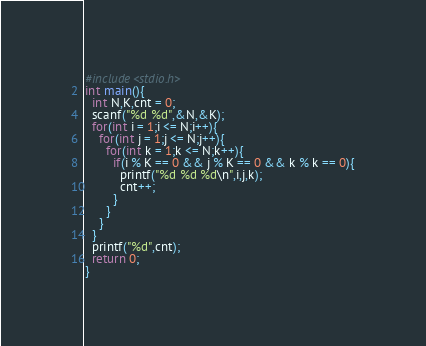Convert code to text. <code><loc_0><loc_0><loc_500><loc_500><_C_>#include<stdio.h>
int main(){
  int N,K,cnt = 0;
  scanf("%d %d",&N,&K);
  for(int i = 1;i <= N;i++){
    for(int j = 1;j <= N;j++){
      for(int k = 1;k <= N;k++){
        if(i % K == 0 && j % K == 0 && k % k == 0){
          printf("%d %d %d\n",i,j,k);
          cnt++;
        }
      }
    }
  }
  printf("%d",cnt);
  return 0;
}</code> 